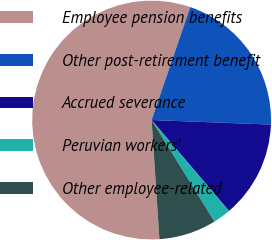Convert chart. <chart><loc_0><loc_0><loc_500><loc_500><pie_chart><fcel>Employee pension benefits<fcel>Other post-retirement benefit<fcel>Accrued severance<fcel>Peruvian workers'<fcel>Other employee-related<nl><fcel>56.29%<fcel>20.36%<fcel>13.17%<fcel>2.4%<fcel>7.78%<nl></chart> 